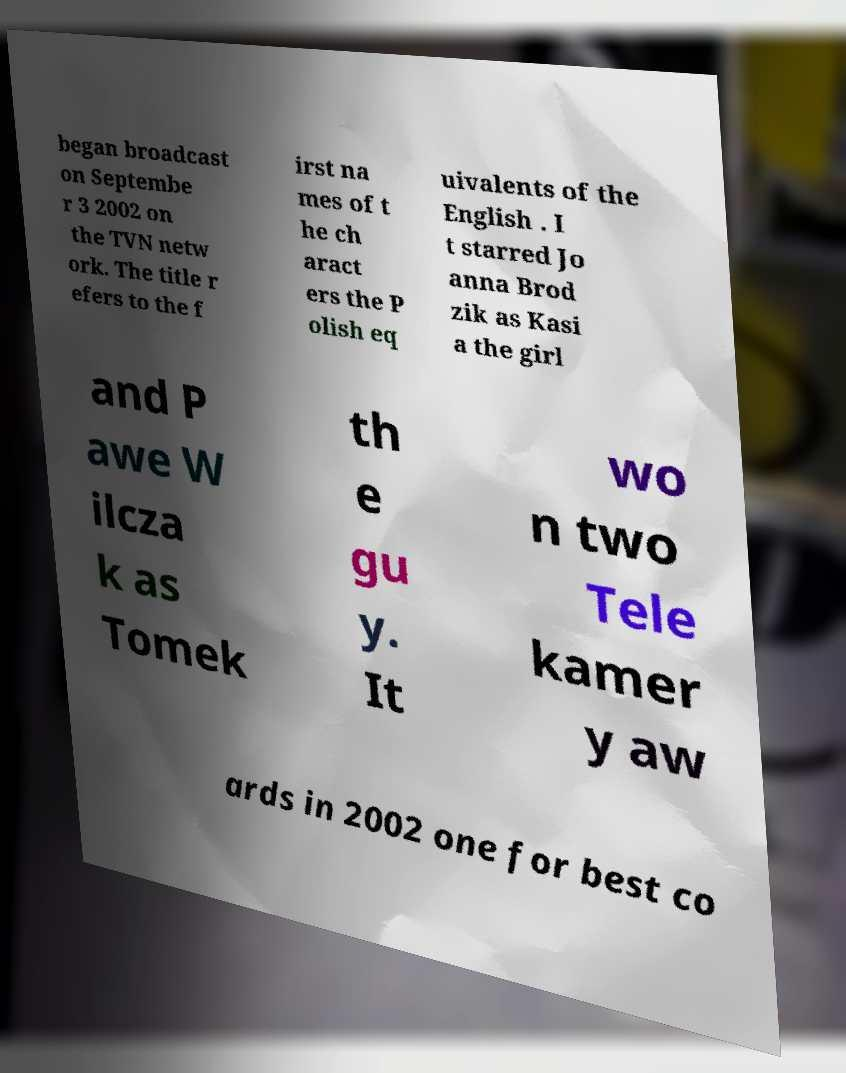What messages or text are displayed in this image? I need them in a readable, typed format. began broadcast on Septembe r 3 2002 on the TVN netw ork. The title r efers to the f irst na mes of t he ch aract ers the P olish eq uivalents of the English . I t starred Jo anna Brod zik as Kasi a the girl and P awe W ilcza k as Tomek th e gu y. It wo n two Tele kamer y aw ards in 2002 one for best co 